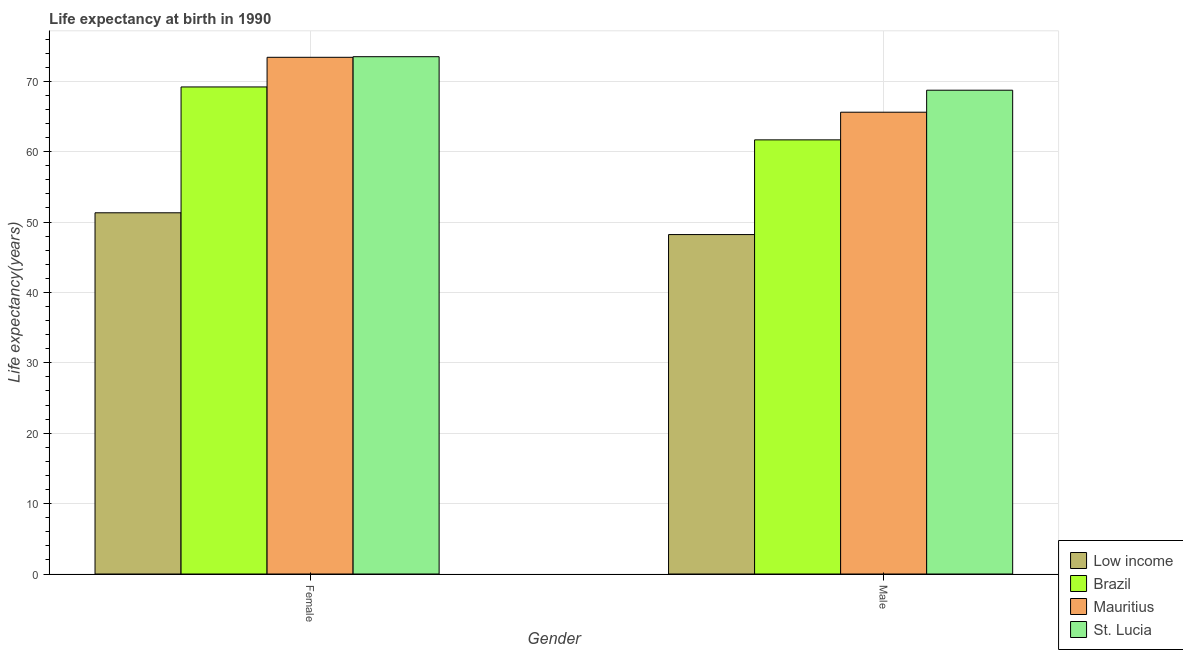Are the number of bars per tick equal to the number of legend labels?
Your answer should be very brief. Yes. How many bars are there on the 2nd tick from the left?
Keep it short and to the point. 4. How many bars are there on the 2nd tick from the right?
Ensure brevity in your answer.  4. What is the life expectancy(female) in St. Lucia?
Your answer should be compact. 73.49. Across all countries, what is the maximum life expectancy(female)?
Keep it short and to the point. 73.49. Across all countries, what is the minimum life expectancy(female)?
Your answer should be compact. 51.31. In which country was the life expectancy(female) maximum?
Your answer should be compact. St. Lucia. What is the total life expectancy(female) in the graph?
Make the answer very short. 267.39. What is the difference between the life expectancy(female) in St. Lucia and that in Low income?
Keep it short and to the point. 22.17. What is the difference between the life expectancy(female) in Brazil and the life expectancy(male) in Low income?
Your answer should be very brief. 20.97. What is the average life expectancy(male) per country?
Give a very brief answer. 61.05. What is the difference between the life expectancy(female) and life expectancy(male) in St. Lucia?
Offer a terse response. 4.76. What is the ratio of the life expectancy(male) in Brazil to that in Low income?
Keep it short and to the point. 1.28. What does the 4th bar from the right in Male represents?
Your response must be concise. Low income. Are all the bars in the graph horizontal?
Give a very brief answer. No. How many countries are there in the graph?
Offer a very short reply. 4. Are the values on the major ticks of Y-axis written in scientific E-notation?
Keep it short and to the point. No. Does the graph contain any zero values?
Your response must be concise. No. How many legend labels are there?
Provide a succinct answer. 4. How are the legend labels stacked?
Ensure brevity in your answer.  Vertical. What is the title of the graph?
Provide a short and direct response. Life expectancy at birth in 1990. Does "Trinidad and Tobago" appear as one of the legend labels in the graph?
Provide a short and direct response. No. What is the label or title of the Y-axis?
Keep it short and to the point. Life expectancy(years). What is the Life expectancy(years) in Low income in Female?
Ensure brevity in your answer.  51.31. What is the Life expectancy(years) of Brazil in Female?
Make the answer very short. 69.19. What is the Life expectancy(years) of Mauritius in Female?
Give a very brief answer. 73.4. What is the Life expectancy(years) of St. Lucia in Female?
Offer a very short reply. 73.49. What is the Life expectancy(years) of Low income in Male?
Provide a succinct answer. 48.22. What is the Life expectancy(years) in Brazil in Male?
Provide a succinct answer. 61.67. What is the Life expectancy(years) of Mauritius in Male?
Provide a short and direct response. 65.6. What is the Life expectancy(years) of St. Lucia in Male?
Keep it short and to the point. 68.73. Across all Gender, what is the maximum Life expectancy(years) in Low income?
Provide a succinct answer. 51.31. Across all Gender, what is the maximum Life expectancy(years) in Brazil?
Your response must be concise. 69.19. Across all Gender, what is the maximum Life expectancy(years) of Mauritius?
Provide a succinct answer. 73.4. Across all Gender, what is the maximum Life expectancy(years) in St. Lucia?
Give a very brief answer. 73.49. Across all Gender, what is the minimum Life expectancy(years) in Low income?
Give a very brief answer. 48.22. Across all Gender, what is the minimum Life expectancy(years) in Brazil?
Keep it short and to the point. 61.67. Across all Gender, what is the minimum Life expectancy(years) in Mauritius?
Give a very brief answer. 65.6. Across all Gender, what is the minimum Life expectancy(years) of St. Lucia?
Make the answer very short. 68.73. What is the total Life expectancy(years) in Low income in the graph?
Your response must be concise. 99.53. What is the total Life expectancy(years) in Brazil in the graph?
Make the answer very short. 130.86. What is the total Life expectancy(years) of Mauritius in the graph?
Give a very brief answer. 139. What is the total Life expectancy(years) of St. Lucia in the graph?
Make the answer very short. 142.22. What is the difference between the Life expectancy(years) of Low income in Female and that in Male?
Offer a terse response. 3.09. What is the difference between the Life expectancy(years) in Brazil in Female and that in Male?
Your response must be concise. 7.52. What is the difference between the Life expectancy(years) in St. Lucia in Female and that in Male?
Your response must be concise. 4.76. What is the difference between the Life expectancy(years) of Low income in Female and the Life expectancy(years) of Brazil in Male?
Your answer should be very brief. -10.36. What is the difference between the Life expectancy(years) in Low income in Female and the Life expectancy(years) in Mauritius in Male?
Your answer should be very brief. -14.29. What is the difference between the Life expectancy(years) in Low income in Female and the Life expectancy(years) in St. Lucia in Male?
Make the answer very short. -17.41. What is the difference between the Life expectancy(years) in Brazil in Female and the Life expectancy(years) in Mauritius in Male?
Ensure brevity in your answer.  3.59. What is the difference between the Life expectancy(years) in Brazil in Female and the Life expectancy(years) in St. Lucia in Male?
Offer a very short reply. 0.46. What is the difference between the Life expectancy(years) in Mauritius in Female and the Life expectancy(years) in St. Lucia in Male?
Provide a short and direct response. 4.67. What is the average Life expectancy(years) of Low income per Gender?
Give a very brief answer. 49.77. What is the average Life expectancy(years) in Brazil per Gender?
Provide a short and direct response. 65.43. What is the average Life expectancy(years) in Mauritius per Gender?
Keep it short and to the point. 69.5. What is the average Life expectancy(years) in St. Lucia per Gender?
Your answer should be compact. 71.11. What is the difference between the Life expectancy(years) in Low income and Life expectancy(years) in Brazil in Female?
Ensure brevity in your answer.  -17.88. What is the difference between the Life expectancy(years) in Low income and Life expectancy(years) in Mauritius in Female?
Offer a very short reply. -22.09. What is the difference between the Life expectancy(years) in Low income and Life expectancy(years) in St. Lucia in Female?
Ensure brevity in your answer.  -22.17. What is the difference between the Life expectancy(years) of Brazil and Life expectancy(years) of Mauritius in Female?
Your response must be concise. -4.21. What is the difference between the Life expectancy(years) of Brazil and Life expectancy(years) of St. Lucia in Female?
Make the answer very short. -4.3. What is the difference between the Life expectancy(years) in Mauritius and Life expectancy(years) in St. Lucia in Female?
Give a very brief answer. -0.09. What is the difference between the Life expectancy(years) in Low income and Life expectancy(years) in Brazil in Male?
Make the answer very short. -13.45. What is the difference between the Life expectancy(years) of Low income and Life expectancy(years) of Mauritius in Male?
Keep it short and to the point. -17.38. What is the difference between the Life expectancy(years) in Low income and Life expectancy(years) in St. Lucia in Male?
Give a very brief answer. -20.51. What is the difference between the Life expectancy(years) of Brazil and Life expectancy(years) of Mauritius in Male?
Make the answer very short. -3.93. What is the difference between the Life expectancy(years) in Brazil and Life expectancy(years) in St. Lucia in Male?
Offer a very short reply. -7.05. What is the difference between the Life expectancy(years) of Mauritius and Life expectancy(years) of St. Lucia in Male?
Provide a short and direct response. -3.13. What is the ratio of the Life expectancy(years) in Low income in Female to that in Male?
Your answer should be very brief. 1.06. What is the ratio of the Life expectancy(years) in Brazil in Female to that in Male?
Offer a very short reply. 1.12. What is the ratio of the Life expectancy(years) of Mauritius in Female to that in Male?
Offer a terse response. 1.12. What is the ratio of the Life expectancy(years) in St. Lucia in Female to that in Male?
Give a very brief answer. 1.07. What is the difference between the highest and the second highest Life expectancy(years) in Low income?
Offer a very short reply. 3.09. What is the difference between the highest and the second highest Life expectancy(years) of Brazil?
Offer a very short reply. 7.52. What is the difference between the highest and the second highest Life expectancy(years) in Mauritius?
Your answer should be very brief. 7.8. What is the difference between the highest and the second highest Life expectancy(years) of St. Lucia?
Your answer should be compact. 4.76. What is the difference between the highest and the lowest Life expectancy(years) of Low income?
Offer a terse response. 3.09. What is the difference between the highest and the lowest Life expectancy(years) of Brazil?
Ensure brevity in your answer.  7.52. What is the difference between the highest and the lowest Life expectancy(years) of St. Lucia?
Your answer should be very brief. 4.76. 